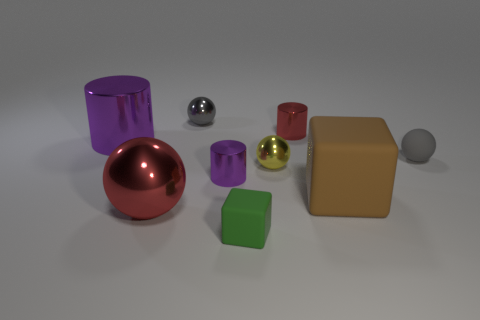Subtract all blocks. How many objects are left? 7 Add 1 matte blocks. How many matte blocks exist? 3 Subtract 0 purple blocks. How many objects are left? 9 Subtract all red metal cylinders. Subtract all brown rubber objects. How many objects are left? 7 Add 5 big cylinders. How many big cylinders are left? 6 